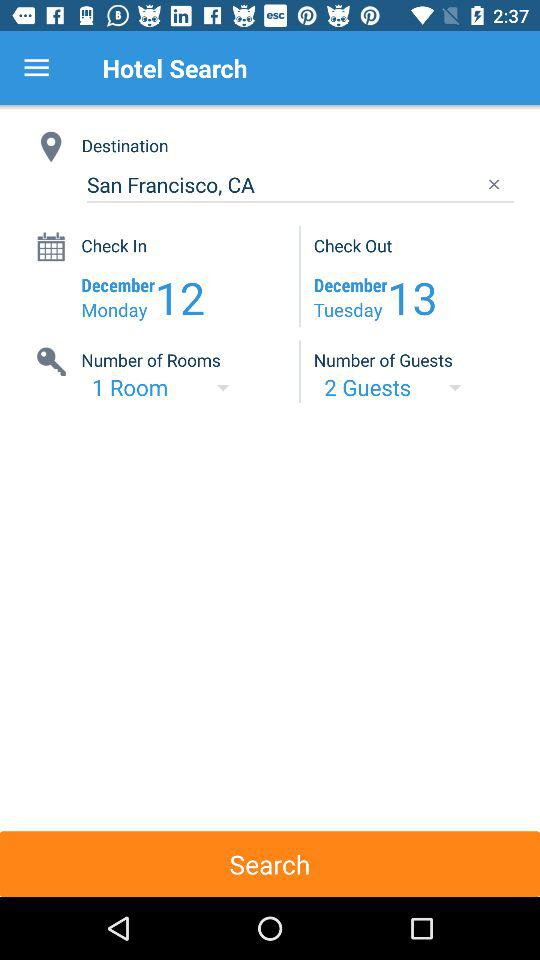What is the destination location? The destination location is San Francisco, CA. 